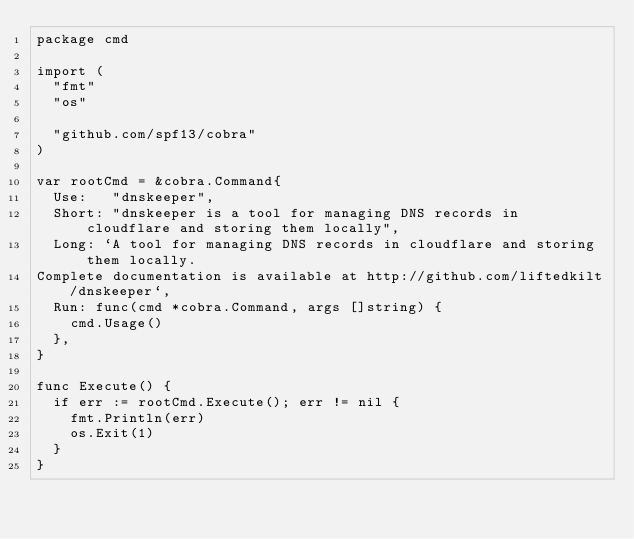Convert code to text. <code><loc_0><loc_0><loc_500><loc_500><_Go_>package cmd

import (
	"fmt"
	"os"

	"github.com/spf13/cobra"
)

var rootCmd = &cobra.Command{
	Use:   "dnskeeper",
	Short: "dnskeeper is a tool for managing DNS records in cloudflare and storing them locally",
	Long: `A tool for managing DNS records in cloudflare and storing them locally.
Complete documentation is available at http://github.com/liftedkilt/dnskeeper`,
	Run: func(cmd *cobra.Command, args []string) {
		cmd.Usage()
	},
}

func Execute() {
	if err := rootCmd.Execute(); err != nil {
		fmt.Println(err)
		os.Exit(1)
	}
}
</code> 